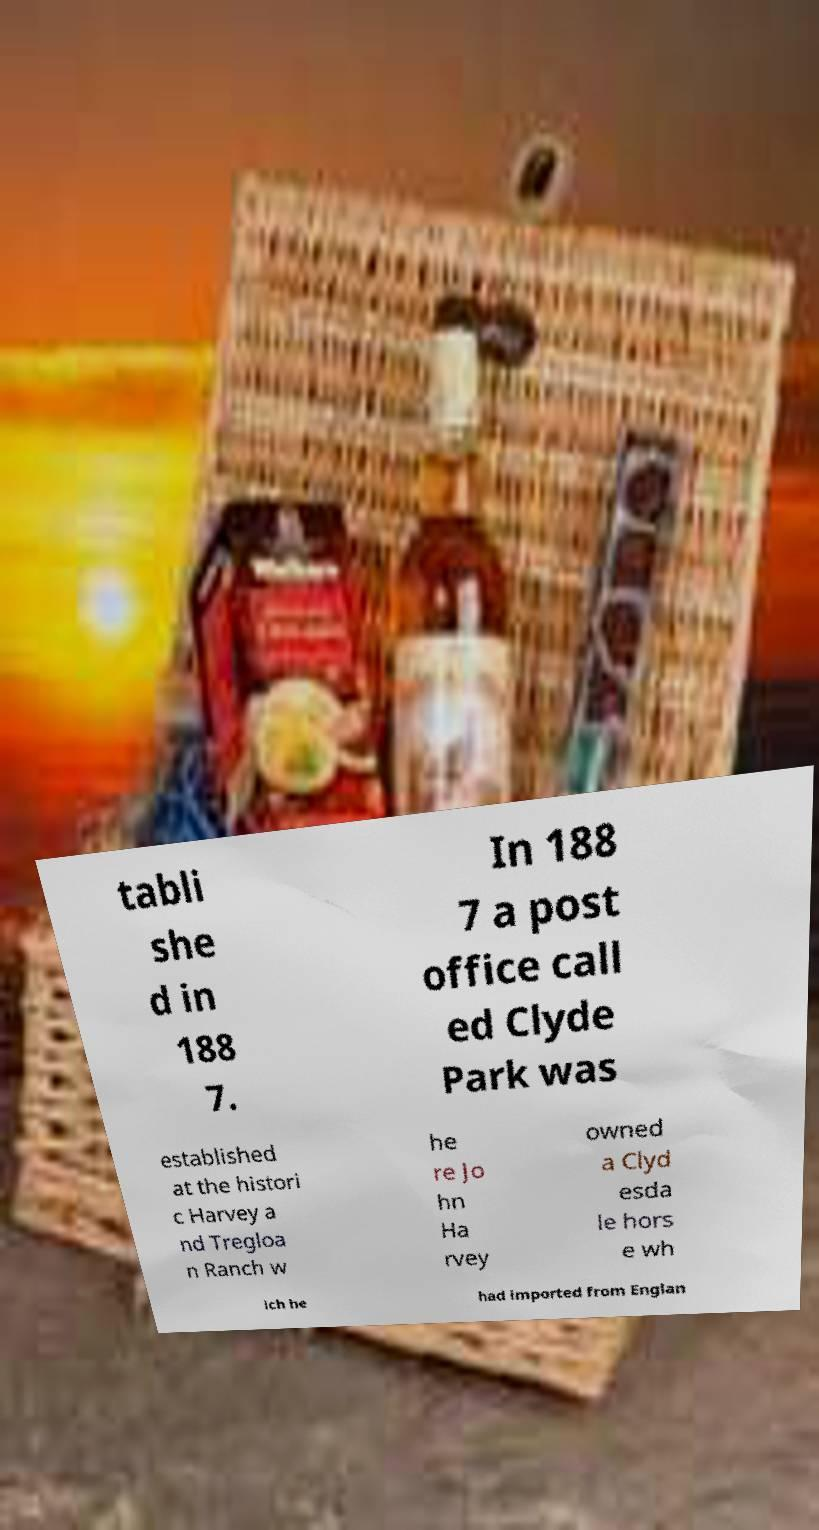For documentation purposes, I need the text within this image transcribed. Could you provide that? tabli she d in 188 7. In 188 7 a post office call ed Clyde Park was established at the histori c Harvey a nd Tregloa n Ranch w he re Jo hn Ha rvey owned a Clyd esda le hors e wh ich he had imported from Englan 